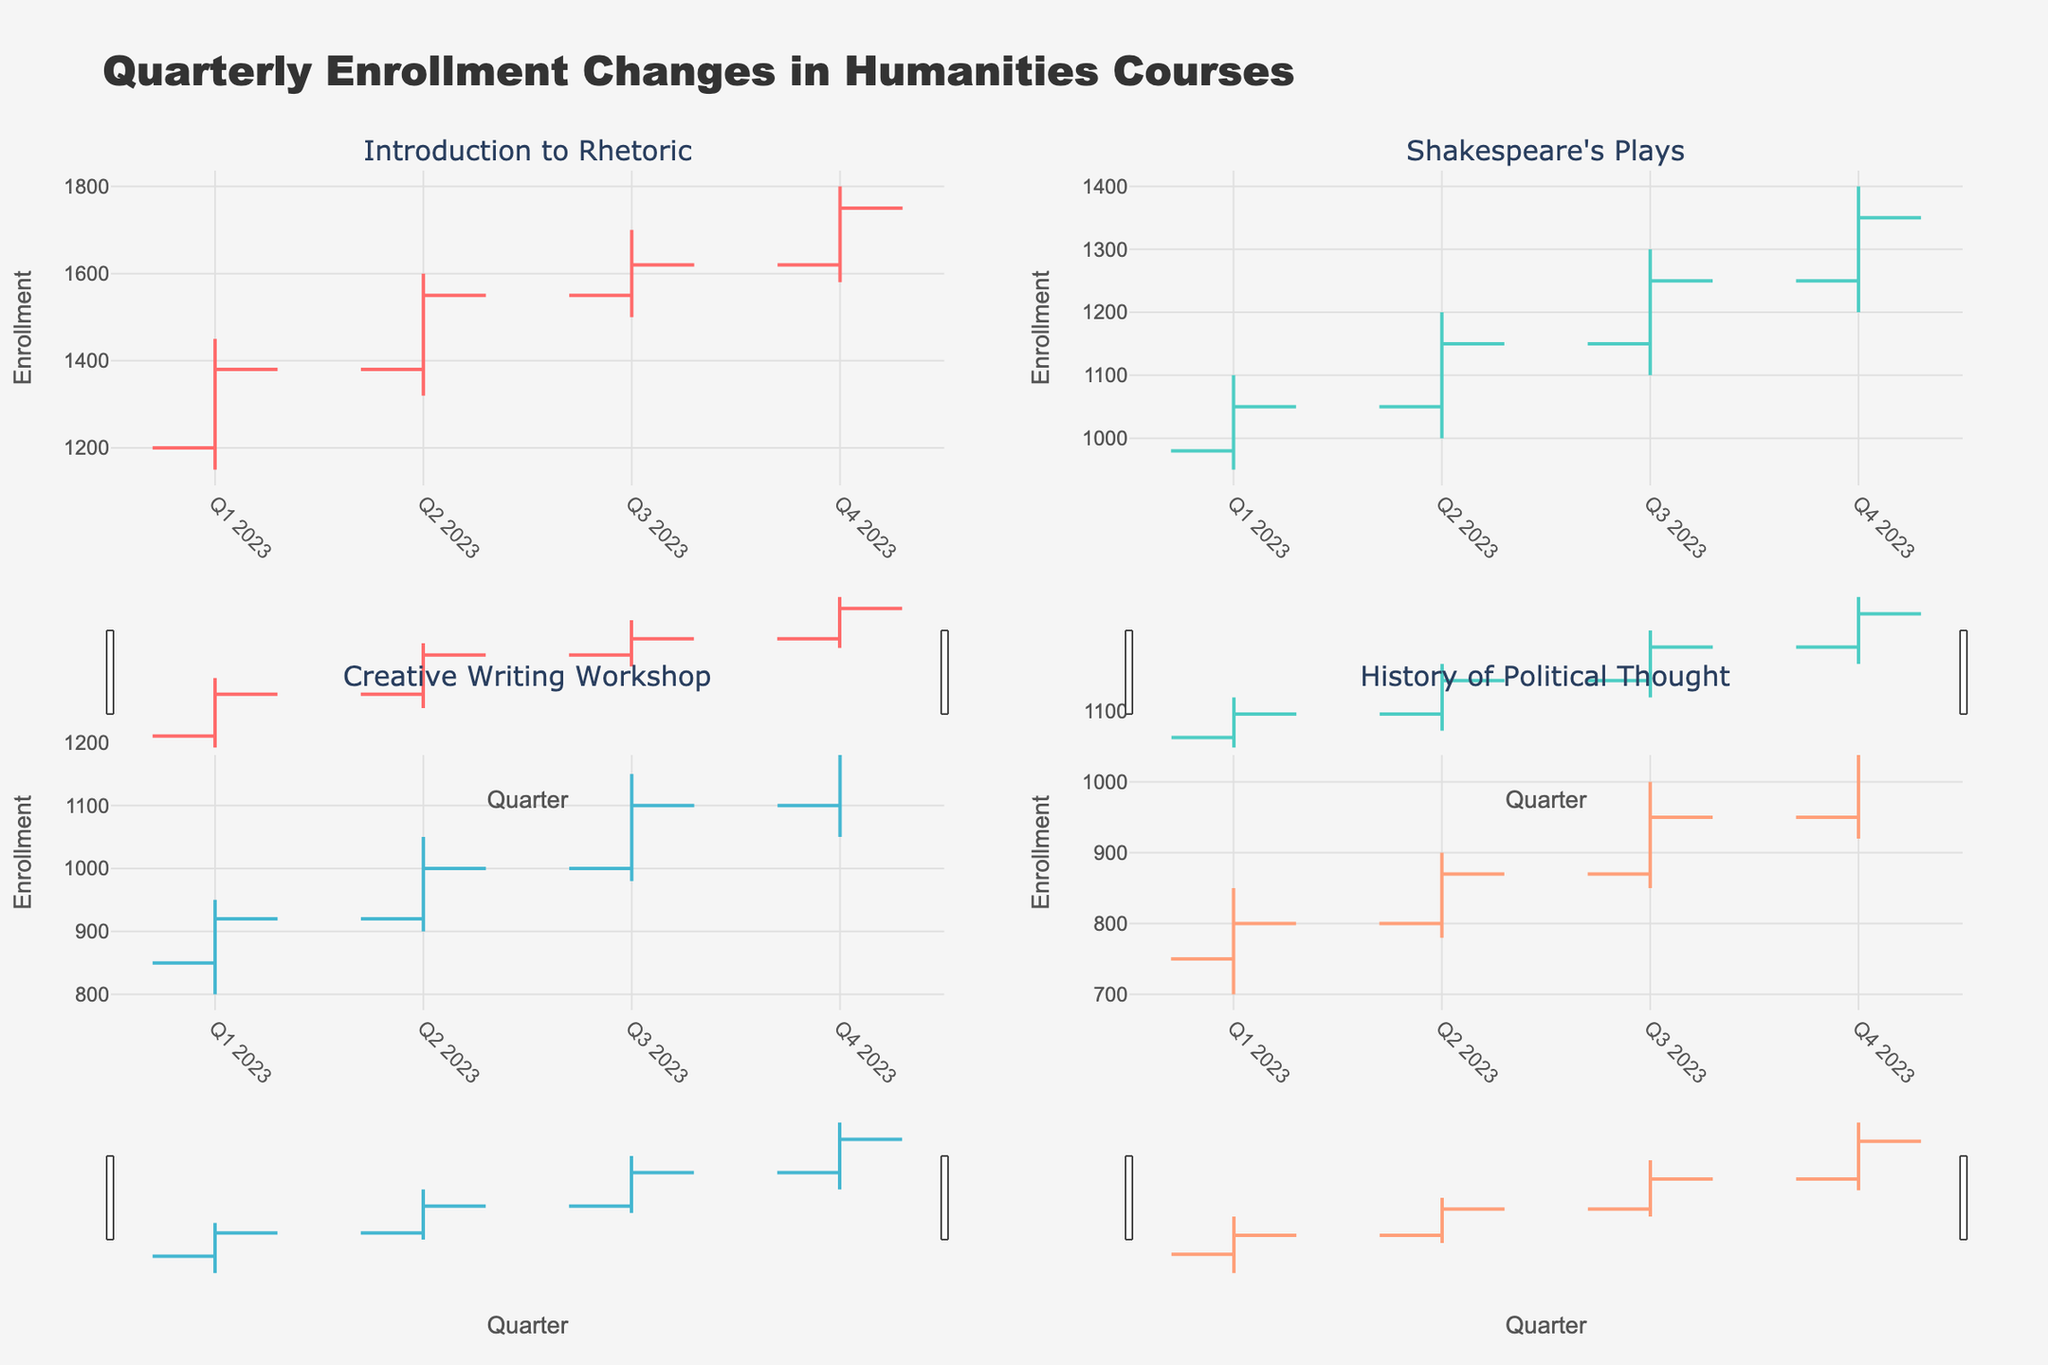What is the title of the figure? The title is placed at the top of the figure and usually summarizes what the figure is about.
Answer: Quarterly Enrollment Changes in Humanities Courses How many courses are displayed in the figure? The figure contains subplots, each representing one course. Counting the subplot titles gives the number of courses.
Answer: 4 Which course had the highest enrollment in Q4 2023? Look for the highest "High" value in Q4 2023 across all subplots. The subplot for “Introduction to Rhetoric” shows the highest point reaching 1800.
Answer: Introduction to Rhetoric What is the range of enrollments for "Shakespeare's Plays" in Q3 2023? The range is calculated by subtracting the "Low" value from the "High" value for "Shakespeare's Plays" in Q3 2023. The values are 1300 and 1100, respectively.
Answer: 200 Did "Creative Writing Workshop" have any quarter where enrollment closed higher than it opened? Compare the "Open" and "Close" values in each quarter for "Creative Writing Workshop" to check if the close is greater than the open. For Q2, Q3, and Q4, the close values are higher than open values.
Answer: Yes By how much did the enrollment in "History of Political Thought" increase from Q1 to Q4 2023? Subtract the "Close" value in Q1 (800) from the "Close" value in Q4 (1050).
Answer: 250 Which quarter showed the greatest increase in enrollment for "Introduction to Rhetoric"? Calculate the differences between the "Close" and "Open" values for each quarter and compare them to find the maximum. The values are 180, 170, 70, and 130 for Q1, Q2, Q3, and Q4, respectively.
Answer: Q2 2023 For "Shakespeare's Plays", which quarter had the smallest range between high and low enrollments? Calculate the ranges for each quarter by subtracting "Low" from "High" and identify the smallest value. The ranges are 150, 200, 200, and 200, for Q1, Q2, Q3, and Q4, respectively.
Answer: Q1 2023 On average, how much did enrollment increase each quarter for "Creative Writing Workshop"? Find the increase for each quarter by subtracting "Open" from "Close" values and then calculate the average. The increases are 70, 80, and 100 for Q2, Q3, and Q4 respectively. Sum these increases (250) and divide by 3 quarters.
Answer: 83.33 Which course showed the most consistent (least volatile) enrollment changes throughout 2023? To determine consistency, compare the ranges (high minus low) of enrollments across all quarters for each course. The course with the smallest average range is considered the most consistent. Upon reviewing ranges: "History of Political Thought" has lower values (150, 120, 150, 180).
Answer: History of Political Thought 